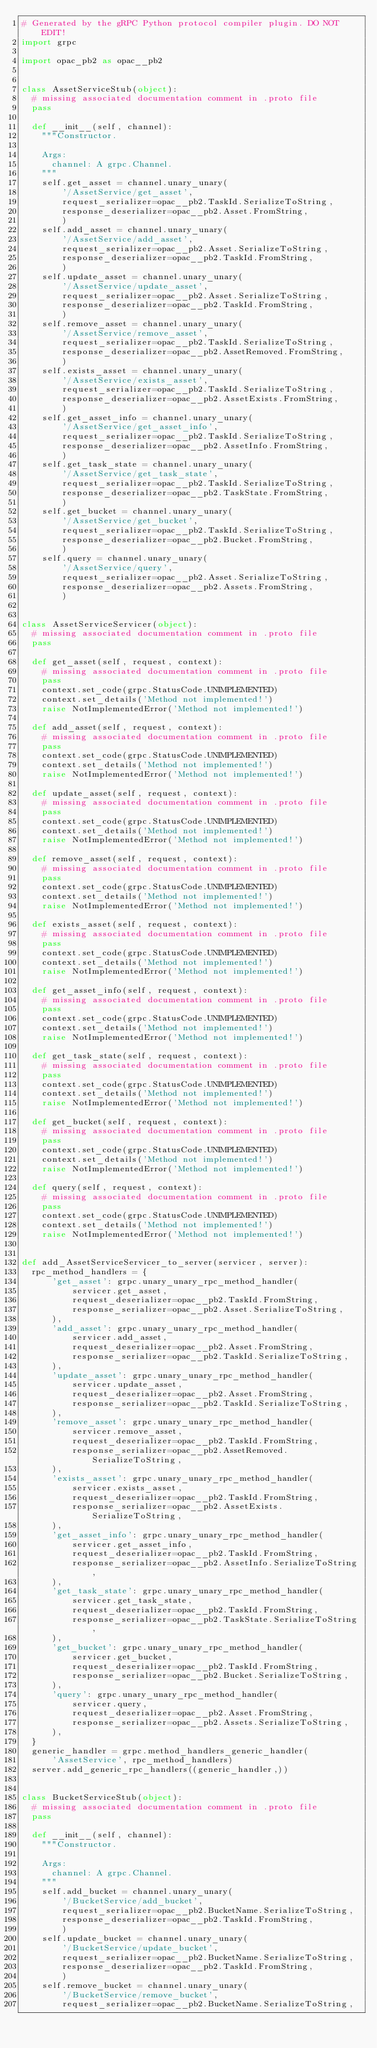<code> <loc_0><loc_0><loc_500><loc_500><_Python_># Generated by the gRPC Python protocol compiler plugin. DO NOT EDIT!
import grpc

import opac_pb2 as opac__pb2


class AssetServiceStub(object):
  # missing associated documentation comment in .proto file
  pass

  def __init__(self, channel):
    """Constructor.

    Args:
      channel: A grpc.Channel.
    """
    self.get_asset = channel.unary_unary(
        '/AssetService/get_asset',
        request_serializer=opac__pb2.TaskId.SerializeToString,
        response_deserializer=opac__pb2.Asset.FromString,
        )
    self.add_asset = channel.unary_unary(
        '/AssetService/add_asset',
        request_serializer=opac__pb2.Asset.SerializeToString,
        response_deserializer=opac__pb2.TaskId.FromString,
        )
    self.update_asset = channel.unary_unary(
        '/AssetService/update_asset',
        request_serializer=opac__pb2.Asset.SerializeToString,
        response_deserializer=opac__pb2.TaskId.FromString,
        )
    self.remove_asset = channel.unary_unary(
        '/AssetService/remove_asset',
        request_serializer=opac__pb2.TaskId.SerializeToString,
        response_deserializer=opac__pb2.AssetRemoved.FromString,
        )
    self.exists_asset = channel.unary_unary(
        '/AssetService/exists_asset',
        request_serializer=opac__pb2.TaskId.SerializeToString,
        response_deserializer=opac__pb2.AssetExists.FromString,
        )
    self.get_asset_info = channel.unary_unary(
        '/AssetService/get_asset_info',
        request_serializer=opac__pb2.TaskId.SerializeToString,
        response_deserializer=opac__pb2.AssetInfo.FromString,
        )
    self.get_task_state = channel.unary_unary(
        '/AssetService/get_task_state',
        request_serializer=opac__pb2.TaskId.SerializeToString,
        response_deserializer=opac__pb2.TaskState.FromString,
        )
    self.get_bucket = channel.unary_unary(
        '/AssetService/get_bucket',
        request_serializer=opac__pb2.TaskId.SerializeToString,
        response_deserializer=opac__pb2.Bucket.FromString,
        )
    self.query = channel.unary_unary(
        '/AssetService/query',
        request_serializer=opac__pb2.Asset.SerializeToString,
        response_deserializer=opac__pb2.Assets.FromString,
        )


class AssetServiceServicer(object):
  # missing associated documentation comment in .proto file
  pass

  def get_asset(self, request, context):
    # missing associated documentation comment in .proto file
    pass
    context.set_code(grpc.StatusCode.UNIMPLEMENTED)
    context.set_details('Method not implemented!')
    raise NotImplementedError('Method not implemented!')

  def add_asset(self, request, context):
    # missing associated documentation comment in .proto file
    pass
    context.set_code(grpc.StatusCode.UNIMPLEMENTED)
    context.set_details('Method not implemented!')
    raise NotImplementedError('Method not implemented!')

  def update_asset(self, request, context):
    # missing associated documentation comment in .proto file
    pass
    context.set_code(grpc.StatusCode.UNIMPLEMENTED)
    context.set_details('Method not implemented!')
    raise NotImplementedError('Method not implemented!')

  def remove_asset(self, request, context):
    # missing associated documentation comment in .proto file
    pass
    context.set_code(grpc.StatusCode.UNIMPLEMENTED)
    context.set_details('Method not implemented!')
    raise NotImplementedError('Method not implemented!')

  def exists_asset(self, request, context):
    # missing associated documentation comment in .proto file
    pass
    context.set_code(grpc.StatusCode.UNIMPLEMENTED)
    context.set_details('Method not implemented!')
    raise NotImplementedError('Method not implemented!')

  def get_asset_info(self, request, context):
    # missing associated documentation comment in .proto file
    pass
    context.set_code(grpc.StatusCode.UNIMPLEMENTED)
    context.set_details('Method not implemented!')
    raise NotImplementedError('Method not implemented!')

  def get_task_state(self, request, context):
    # missing associated documentation comment in .proto file
    pass
    context.set_code(grpc.StatusCode.UNIMPLEMENTED)
    context.set_details('Method not implemented!')
    raise NotImplementedError('Method not implemented!')

  def get_bucket(self, request, context):
    # missing associated documentation comment in .proto file
    pass
    context.set_code(grpc.StatusCode.UNIMPLEMENTED)
    context.set_details('Method not implemented!')
    raise NotImplementedError('Method not implemented!')

  def query(self, request, context):
    # missing associated documentation comment in .proto file
    pass
    context.set_code(grpc.StatusCode.UNIMPLEMENTED)
    context.set_details('Method not implemented!')
    raise NotImplementedError('Method not implemented!')


def add_AssetServiceServicer_to_server(servicer, server):
  rpc_method_handlers = {
      'get_asset': grpc.unary_unary_rpc_method_handler(
          servicer.get_asset,
          request_deserializer=opac__pb2.TaskId.FromString,
          response_serializer=opac__pb2.Asset.SerializeToString,
      ),
      'add_asset': grpc.unary_unary_rpc_method_handler(
          servicer.add_asset,
          request_deserializer=opac__pb2.Asset.FromString,
          response_serializer=opac__pb2.TaskId.SerializeToString,
      ),
      'update_asset': grpc.unary_unary_rpc_method_handler(
          servicer.update_asset,
          request_deserializer=opac__pb2.Asset.FromString,
          response_serializer=opac__pb2.TaskId.SerializeToString,
      ),
      'remove_asset': grpc.unary_unary_rpc_method_handler(
          servicer.remove_asset,
          request_deserializer=opac__pb2.TaskId.FromString,
          response_serializer=opac__pb2.AssetRemoved.SerializeToString,
      ),
      'exists_asset': grpc.unary_unary_rpc_method_handler(
          servicer.exists_asset,
          request_deserializer=opac__pb2.TaskId.FromString,
          response_serializer=opac__pb2.AssetExists.SerializeToString,
      ),
      'get_asset_info': grpc.unary_unary_rpc_method_handler(
          servicer.get_asset_info,
          request_deserializer=opac__pb2.TaskId.FromString,
          response_serializer=opac__pb2.AssetInfo.SerializeToString,
      ),
      'get_task_state': grpc.unary_unary_rpc_method_handler(
          servicer.get_task_state,
          request_deserializer=opac__pb2.TaskId.FromString,
          response_serializer=opac__pb2.TaskState.SerializeToString,
      ),
      'get_bucket': grpc.unary_unary_rpc_method_handler(
          servicer.get_bucket,
          request_deserializer=opac__pb2.TaskId.FromString,
          response_serializer=opac__pb2.Bucket.SerializeToString,
      ),
      'query': grpc.unary_unary_rpc_method_handler(
          servicer.query,
          request_deserializer=opac__pb2.Asset.FromString,
          response_serializer=opac__pb2.Assets.SerializeToString,
      ),
  }
  generic_handler = grpc.method_handlers_generic_handler(
      'AssetService', rpc_method_handlers)
  server.add_generic_rpc_handlers((generic_handler,))


class BucketServiceStub(object):
  # missing associated documentation comment in .proto file
  pass

  def __init__(self, channel):
    """Constructor.

    Args:
      channel: A grpc.Channel.
    """
    self.add_bucket = channel.unary_unary(
        '/BucketService/add_bucket',
        request_serializer=opac__pb2.BucketName.SerializeToString,
        response_deserializer=opac__pb2.TaskId.FromString,
        )
    self.update_bucket = channel.unary_unary(
        '/BucketService/update_bucket',
        request_serializer=opac__pb2.BucketName.SerializeToString,
        response_deserializer=opac__pb2.TaskId.FromString,
        )
    self.remove_bucket = channel.unary_unary(
        '/BucketService/remove_bucket',
        request_serializer=opac__pb2.BucketName.SerializeToString,</code> 